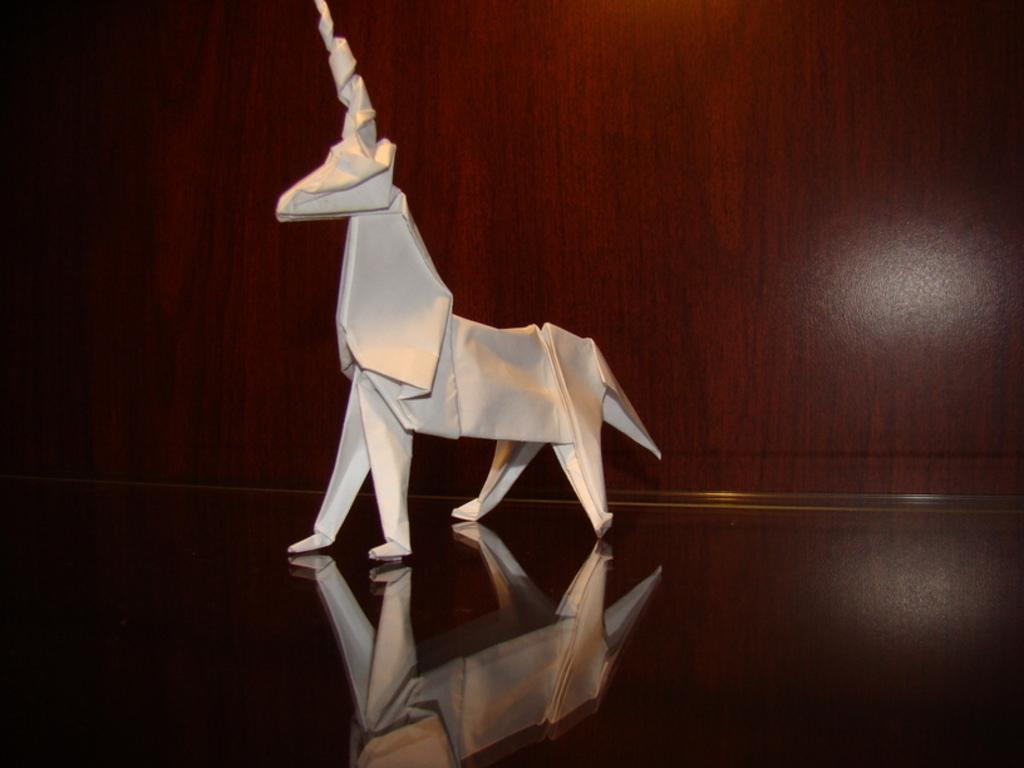What is the main subject of the image? There is an origami deer in the image. What type of surface is the origami deer placed on? The origami deer is placed on a wooden surface. What color is the eye of the oven in the image? There is no oven present in the image, and therefore no eye to describe. 